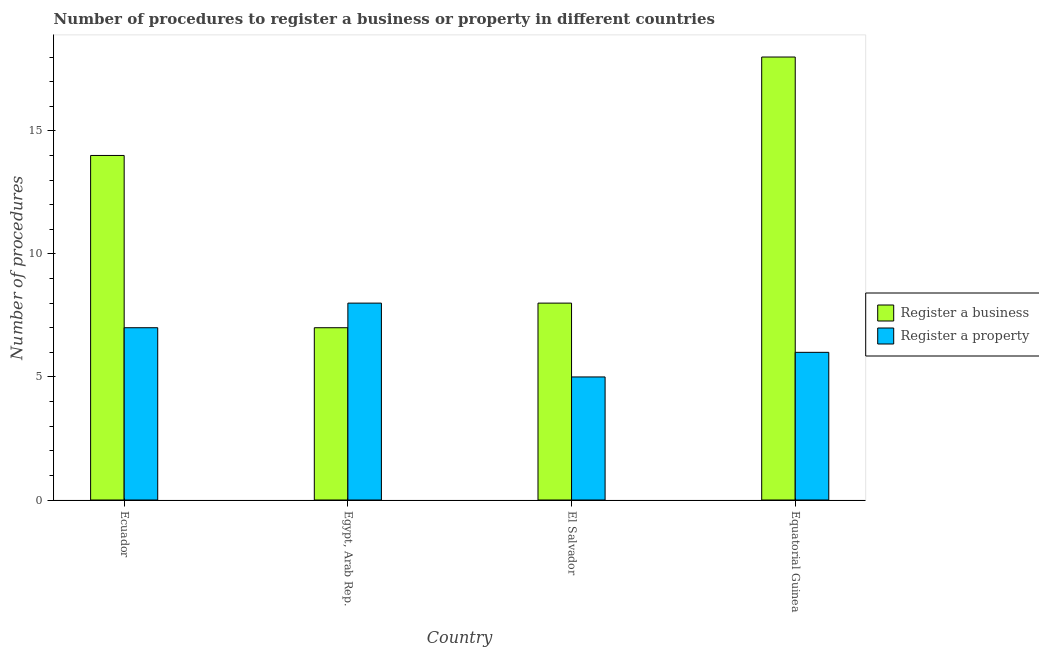How many bars are there on the 1st tick from the right?
Ensure brevity in your answer.  2. What is the label of the 4th group of bars from the left?
Give a very brief answer. Equatorial Guinea. In how many cases, is the number of bars for a given country not equal to the number of legend labels?
Provide a succinct answer. 0. What is the number of procedures to register a business in El Salvador?
Your answer should be compact. 8. In which country was the number of procedures to register a property maximum?
Provide a succinct answer. Egypt, Arab Rep. In which country was the number of procedures to register a property minimum?
Your answer should be compact. El Salvador. What is the difference between the number of procedures to register a business in Equatorial Guinea and the number of procedures to register a property in El Salvador?
Offer a terse response. 13. What is the average number of procedures to register a business per country?
Your answer should be very brief. 11.75. What is the difference between the number of procedures to register a property and number of procedures to register a business in Egypt, Arab Rep.?
Your answer should be very brief. 1. What is the ratio of the number of procedures to register a business in Egypt, Arab Rep. to that in Equatorial Guinea?
Provide a succinct answer. 0.39. Is the difference between the number of procedures to register a property in Egypt, Arab Rep. and Equatorial Guinea greater than the difference between the number of procedures to register a business in Egypt, Arab Rep. and Equatorial Guinea?
Offer a very short reply. Yes. What is the difference between the highest and the second highest number of procedures to register a property?
Keep it short and to the point. 1. What is the difference between the highest and the lowest number of procedures to register a business?
Your answer should be compact. 11. In how many countries, is the number of procedures to register a property greater than the average number of procedures to register a property taken over all countries?
Your answer should be very brief. 2. What does the 2nd bar from the left in Ecuador represents?
Provide a succinct answer. Register a property. What does the 2nd bar from the right in Egypt, Arab Rep. represents?
Ensure brevity in your answer.  Register a business. What is the difference between two consecutive major ticks on the Y-axis?
Offer a very short reply. 5. Are the values on the major ticks of Y-axis written in scientific E-notation?
Keep it short and to the point. No. Does the graph contain any zero values?
Ensure brevity in your answer.  No. Does the graph contain grids?
Ensure brevity in your answer.  No. Where does the legend appear in the graph?
Provide a short and direct response. Center right. How are the legend labels stacked?
Make the answer very short. Vertical. What is the title of the graph?
Keep it short and to the point. Number of procedures to register a business or property in different countries. What is the label or title of the Y-axis?
Make the answer very short. Number of procedures. What is the Number of procedures in Register a property in Egypt, Arab Rep.?
Provide a short and direct response. 8. What is the Number of procedures of Register a property in El Salvador?
Offer a very short reply. 5. What is the Number of procedures of Register a business in Equatorial Guinea?
Offer a very short reply. 18. Across all countries, what is the maximum Number of procedures in Register a business?
Offer a terse response. 18. Across all countries, what is the minimum Number of procedures of Register a business?
Give a very brief answer. 7. Across all countries, what is the minimum Number of procedures of Register a property?
Offer a terse response. 5. What is the total Number of procedures in Register a property in the graph?
Your answer should be compact. 26. What is the difference between the Number of procedures in Register a business in Ecuador and that in Egypt, Arab Rep.?
Your answer should be very brief. 7. What is the difference between the Number of procedures of Register a property in Ecuador and that in Egypt, Arab Rep.?
Keep it short and to the point. -1. What is the difference between the Number of procedures of Register a property in Ecuador and that in El Salvador?
Your response must be concise. 2. What is the difference between the Number of procedures of Register a property in Ecuador and that in Equatorial Guinea?
Provide a succinct answer. 1. What is the difference between the Number of procedures in Register a property in Egypt, Arab Rep. and that in El Salvador?
Your answer should be very brief. 3. What is the difference between the Number of procedures in Register a business in Ecuador and the Number of procedures in Register a property in El Salvador?
Your answer should be very brief. 9. What is the difference between the Number of procedures in Register a business in Ecuador and the Number of procedures in Register a property in Equatorial Guinea?
Make the answer very short. 8. What is the difference between the Number of procedures of Register a business in Egypt, Arab Rep. and the Number of procedures of Register a property in El Salvador?
Ensure brevity in your answer.  2. What is the average Number of procedures in Register a business per country?
Offer a very short reply. 11.75. What is the average Number of procedures in Register a property per country?
Keep it short and to the point. 6.5. What is the difference between the Number of procedures of Register a business and Number of procedures of Register a property in Egypt, Arab Rep.?
Your answer should be very brief. -1. What is the difference between the Number of procedures in Register a business and Number of procedures in Register a property in El Salvador?
Your answer should be very brief. 3. What is the difference between the Number of procedures of Register a business and Number of procedures of Register a property in Equatorial Guinea?
Make the answer very short. 12. What is the ratio of the Number of procedures in Register a business in Ecuador to that in El Salvador?
Provide a short and direct response. 1.75. What is the ratio of the Number of procedures of Register a business in Ecuador to that in Equatorial Guinea?
Your answer should be very brief. 0.78. What is the ratio of the Number of procedures of Register a property in Egypt, Arab Rep. to that in El Salvador?
Provide a short and direct response. 1.6. What is the ratio of the Number of procedures of Register a business in Egypt, Arab Rep. to that in Equatorial Guinea?
Provide a short and direct response. 0.39. What is the ratio of the Number of procedures in Register a business in El Salvador to that in Equatorial Guinea?
Provide a short and direct response. 0.44. What is the ratio of the Number of procedures in Register a property in El Salvador to that in Equatorial Guinea?
Offer a very short reply. 0.83. What is the difference between the highest and the second highest Number of procedures in Register a business?
Offer a terse response. 4. 